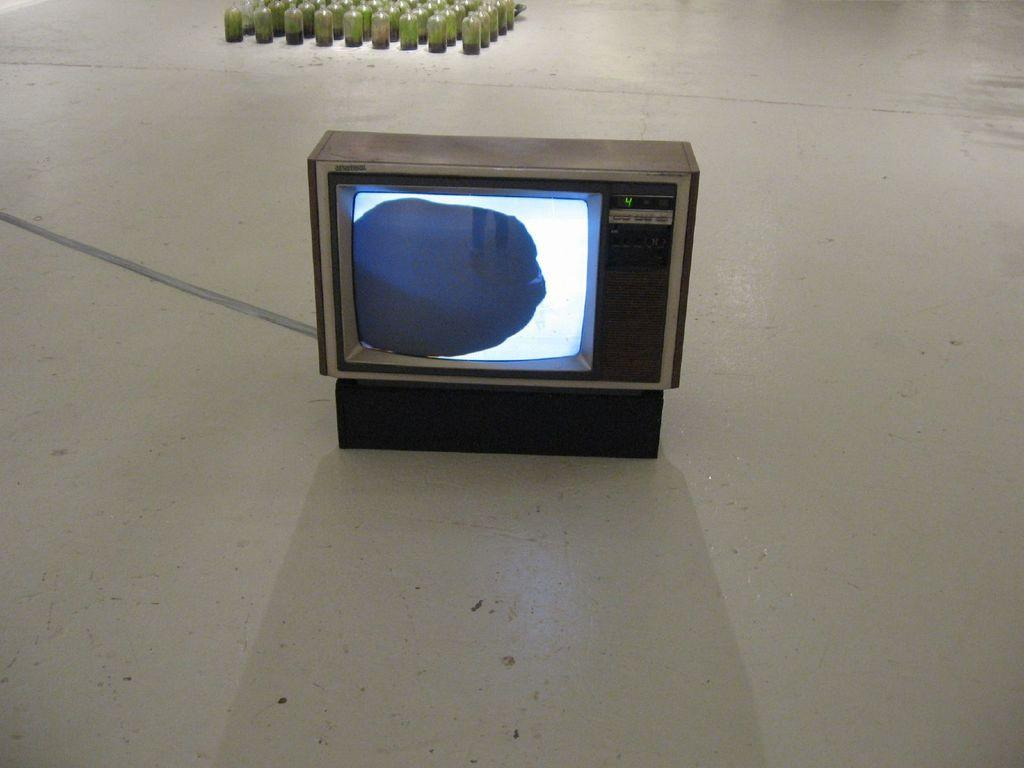<image>
Give a short and clear explanation of the subsequent image. A large old fashioned TV showing it is on channel 4. 